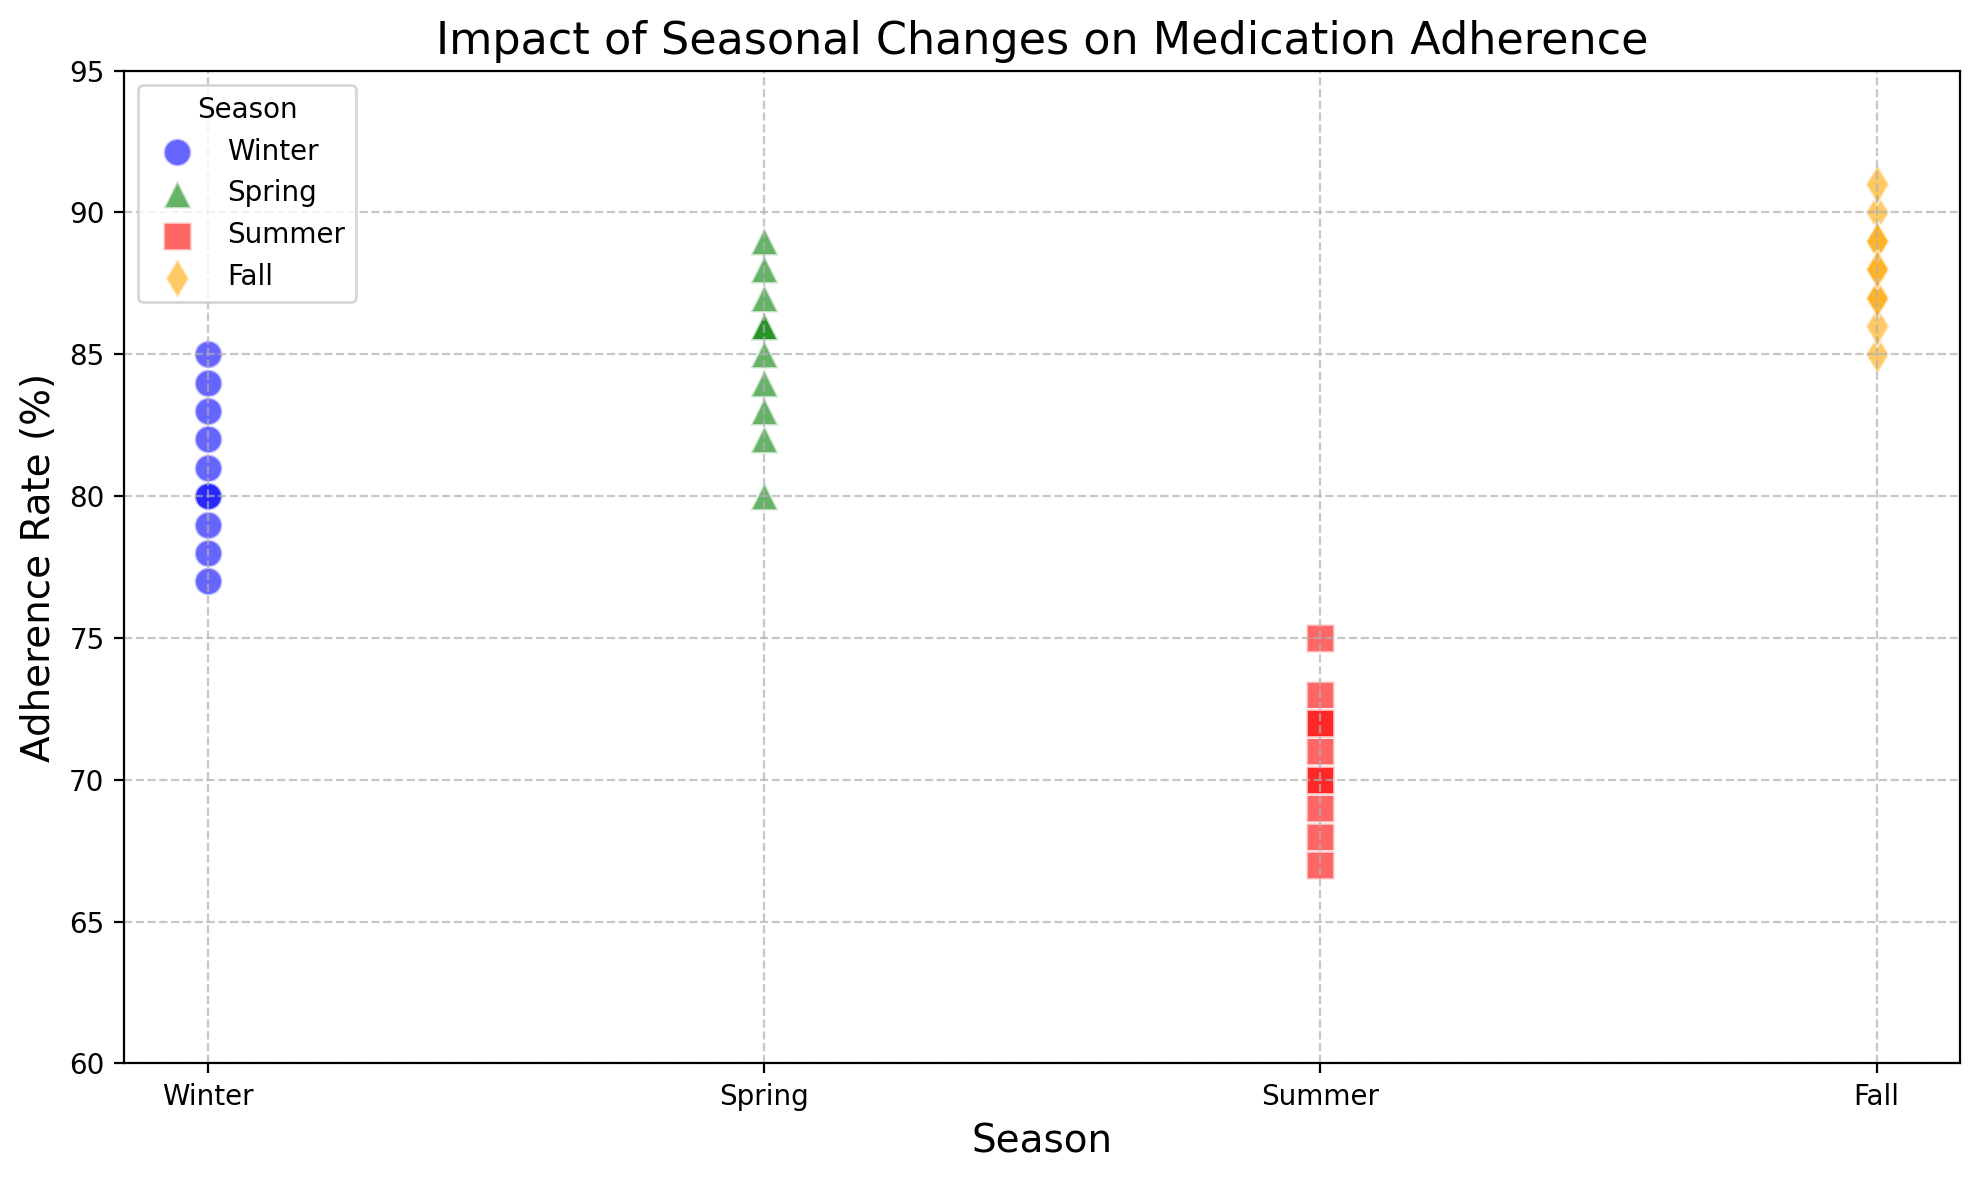What's the adherence rate range in summer? Observing the scatter plot, the adherence rates for summer data points are between 67 and 75.
Answer: 67 to 75 Which season shows the highest adherence rate? Looking at the scatter plot, the adherence rate in fall ranges between 85 and 91, which is higher compared to other seasons.
Answer: Fall What's the average adherence rate in spring? The adherence rates in spring are 88, 85, 86, 84, 89, 87, 83, 80, 82, and 86. Summing these gives 850. Dividing by the number of data points (10) results in an average of 85.
Answer: 85 In which season is the variability of adherence rates the lowest? By visually inspecting the scatter plot, the adherence rates in fall range narrowly between 85 and 91, indicating lower variability compared to other seasons.
Answer: Fall Compare the adherence rate between winter and summer. Winter adherence rates range from 77 to 85, while summer adherence rates range from 67 to 75. Visually, winter adherence rates are higher and less variable than summer.
Answer: Winter adherence rates are higher How does the highest adherence rate in fall compare to the highest adherence rate in spring? The highest adherence rate in fall is 91, while in spring it is 89. Therefore, the fall adherence rate is higher.
Answer: Fall adherence is higher Is there a significant drop in adherence rates in any specific season? By examining the plot, adherence rates drop significantly in summer where the range is from 67 to 75, lower than other seasons.
Answer: Summer Which season has adherence rates closest to 80% on average? Calculate the average adherence rates: Winter (80.5), Spring (85), Summer (70.2), Fall (87.2). Winter's average of 80.5% is closest to 80%.
Answer: Winter What is the maximum adherence rate observed in winter? By observing the scatter plot, the highest adherence rate in winter is seen at 85%.
Answer: 85% How does the adherence variability in winter compare to that in spring? The adherence rate in winter varies from 77 to 85 (range = 8), while in spring it varies from 80 to 89 (range = 9). The variability is slightly lower in winter.
Answer: Winter has slightly lower variability 